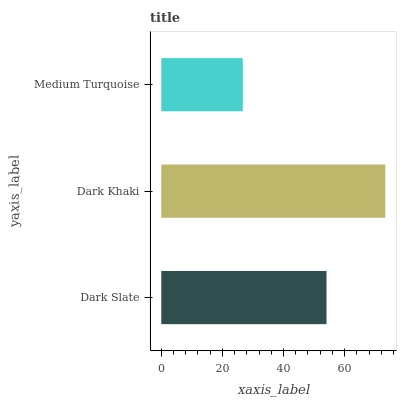Is Medium Turquoise the minimum?
Answer yes or no. Yes. Is Dark Khaki the maximum?
Answer yes or no. Yes. Is Dark Khaki the minimum?
Answer yes or no. No. Is Medium Turquoise the maximum?
Answer yes or no. No. Is Dark Khaki greater than Medium Turquoise?
Answer yes or no. Yes. Is Medium Turquoise less than Dark Khaki?
Answer yes or no. Yes. Is Medium Turquoise greater than Dark Khaki?
Answer yes or no. No. Is Dark Khaki less than Medium Turquoise?
Answer yes or no. No. Is Dark Slate the high median?
Answer yes or no. Yes. Is Dark Slate the low median?
Answer yes or no. Yes. Is Medium Turquoise the high median?
Answer yes or no. No. Is Dark Khaki the low median?
Answer yes or no. No. 